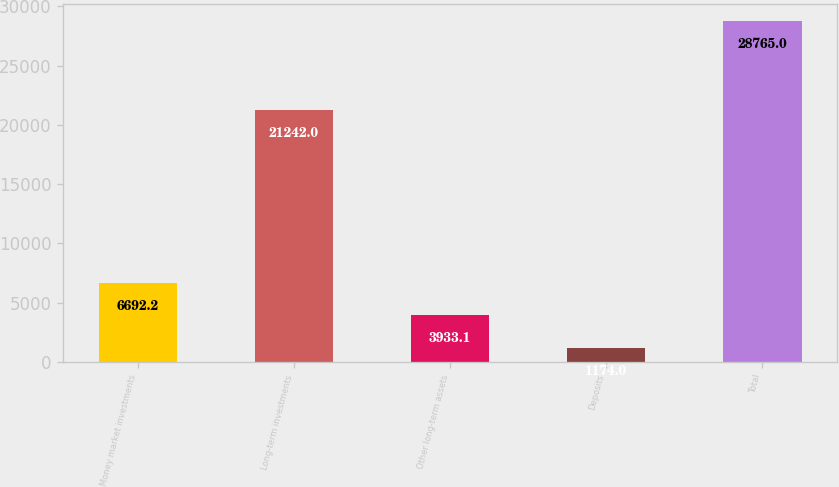Convert chart. <chart><loc_0><loc_0><loc_500><loc_500><bar_chart><fcel>Money market investments<fcel>Long-term investments<fcel>Other long-term assets<fcel>Deposits<fcel>Total<nl><fcel>6692.2<fcel>21242<fcel>3933.1<fcel>1174<fcel>28765<nl></chart> 